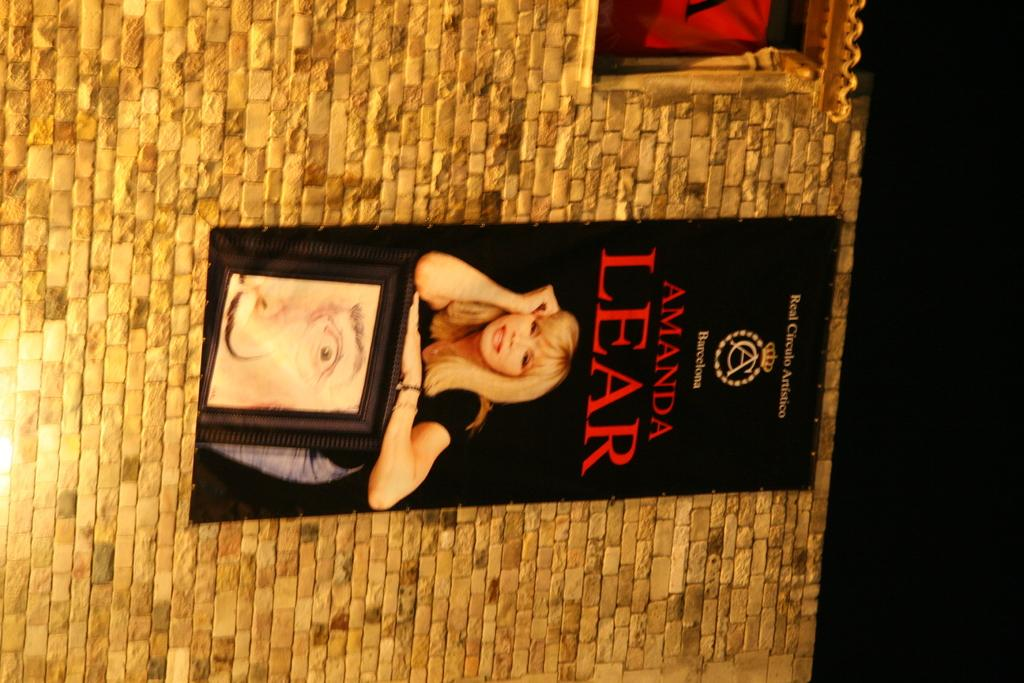How is the image oriented? The image is tilted. What can be seen on the wall in the image? There is a black poster attached to the wall. What is depicted on the poster? The poster contains an image of a woman. What color is the background of the wall in the image? The background of the wall is black. Where is the faucet located in the image? There is no faucet present in the image. What type of dress is the woman wearing in the image? The image is a poster, and the woman depicted on it is not wearing a dress. 